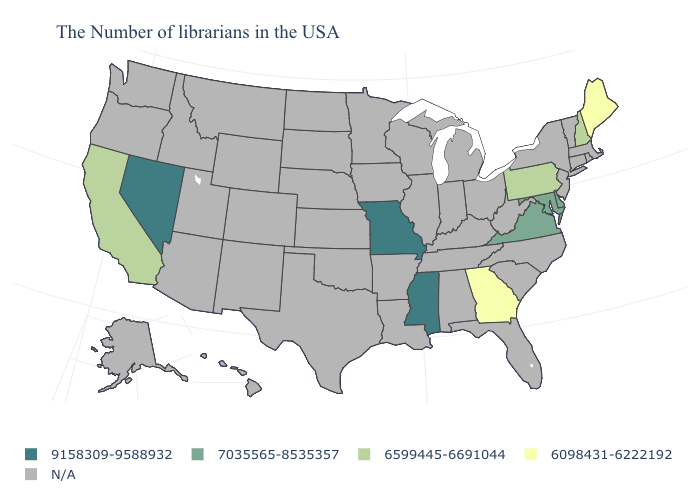What is the value of Connecticut?
Quick response, please. N/A. Does the map have missing data?
Be succinct. Yes. Name the states that have a value in the range 7035565-8535357?
Quick response, please. Delaware, Maryland, Virginia. Name the states that have a value in the range 7035565-8535357?
Write a very short answer. Delaware, Maryland, Virginia. Name the states that have a value in the range 6599445-6691044?
Be succinct. New Hampshire, Pennsylvania, California. Among the states that border Massachusetts , which have the highest value?
Be succinct. New Hampshire. Among the states that border Arizona , does Nevada have the lowest value?
Answer briefly. No. What is the lowest value in the USA?
Give a very brief answer. 6098431-6222192. Which states have the lowest value in the Northeast?
Concise answer only. Maine. What is the lowest value in the USA?
Concise answer only. 6098431-6222192. Which states hav the highest value in the Northeast?
Keep it brief. New Hampshire, Pennsylvania. 